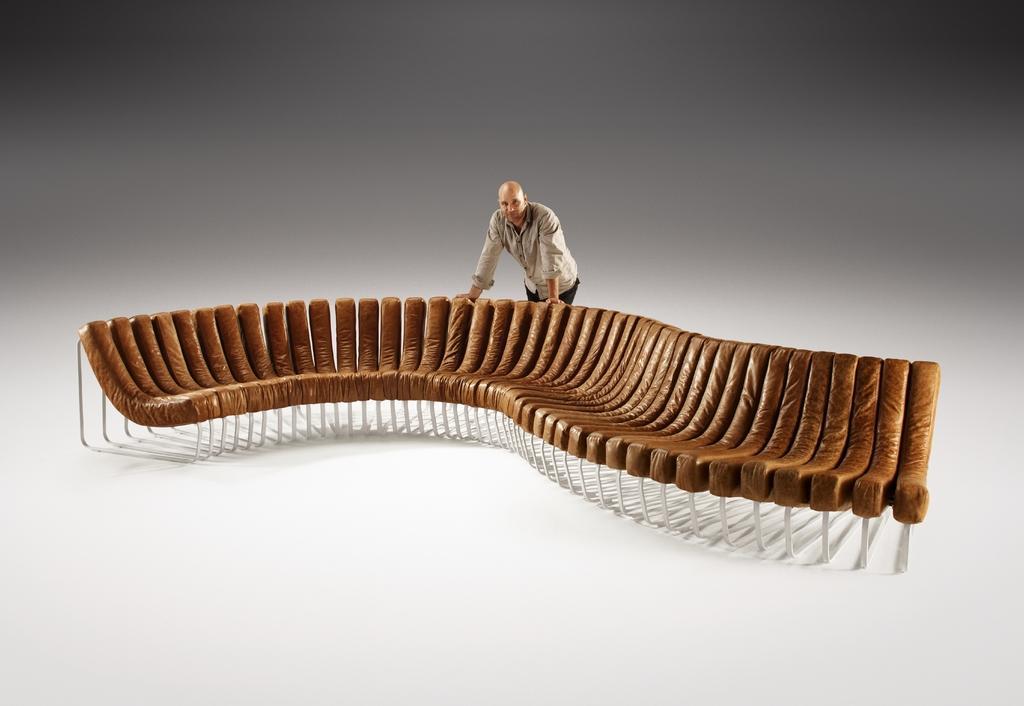In one or two sentences, can you explain what this image depicts? In the center of the image, we can see a sofa and there is a man. 